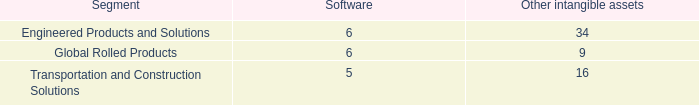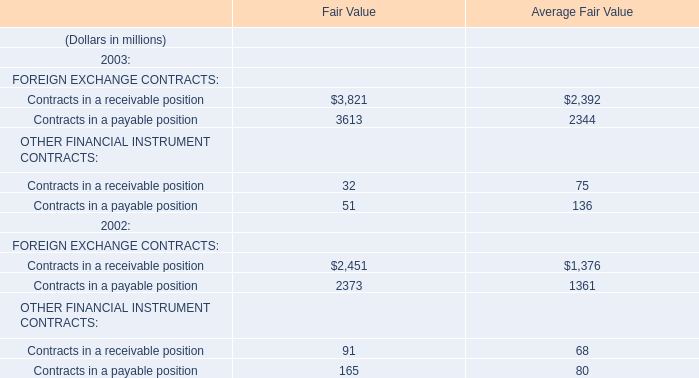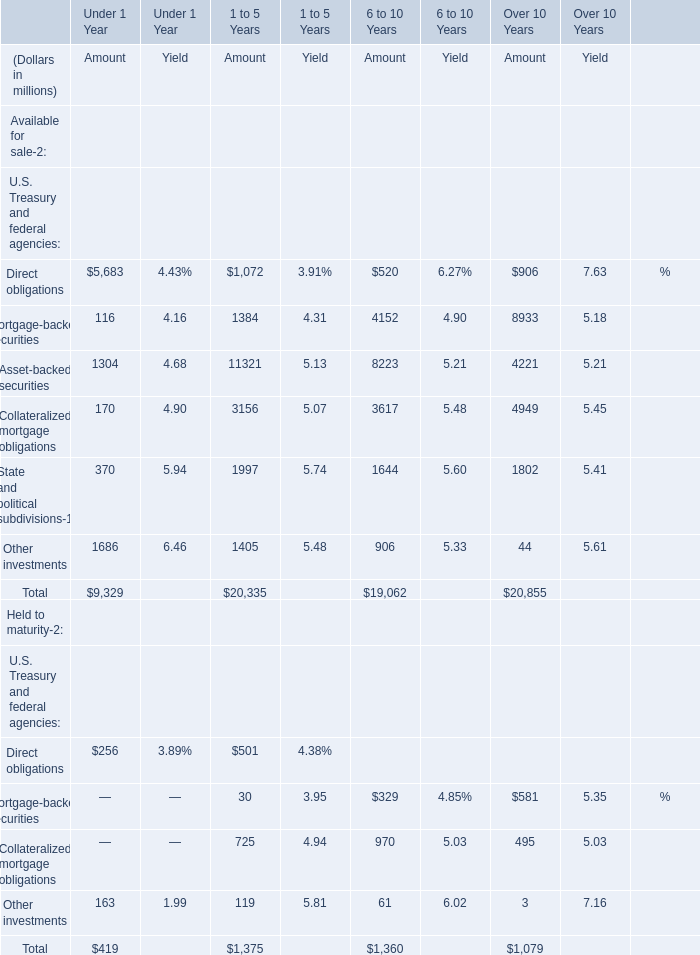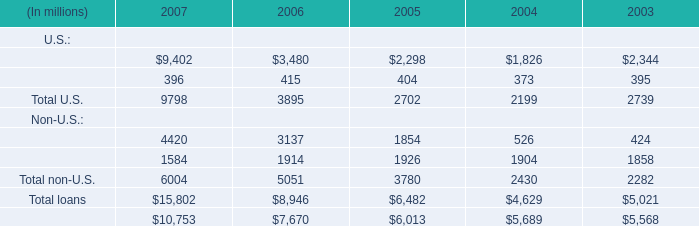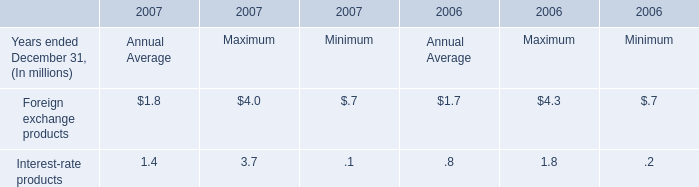What is the proportion of Commercial and financial to the Total in 2007? 
Computations: ((9402 + 4420) / 15802)
Answer: 0.8747. 